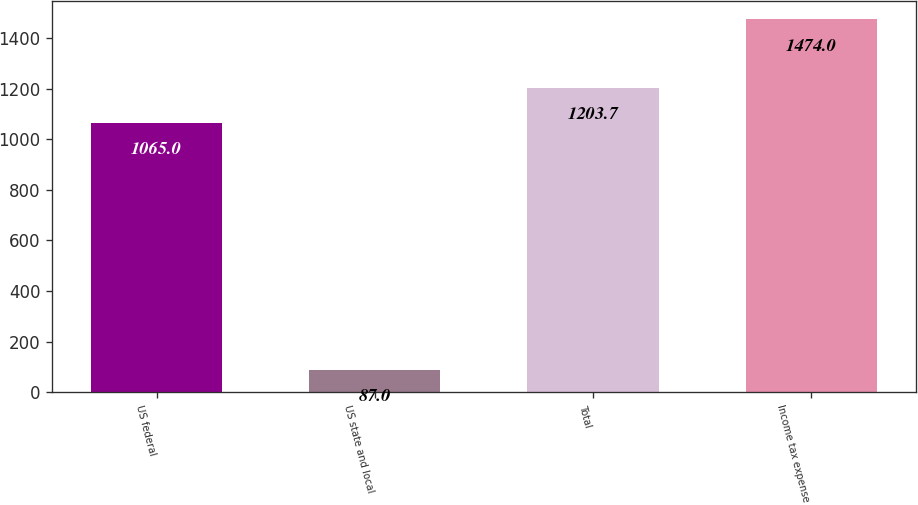Convert chart to OTSL. <chart><loc_0><loc_0><loc_500><loc_500><bar_chart><fcel>US federal<fcel>US state and local<fcel>Total<fcel>Income tax expense<nl><fcel>1065<fcel>87<fcel>1203.7<fcel>1474<nl></chart> 